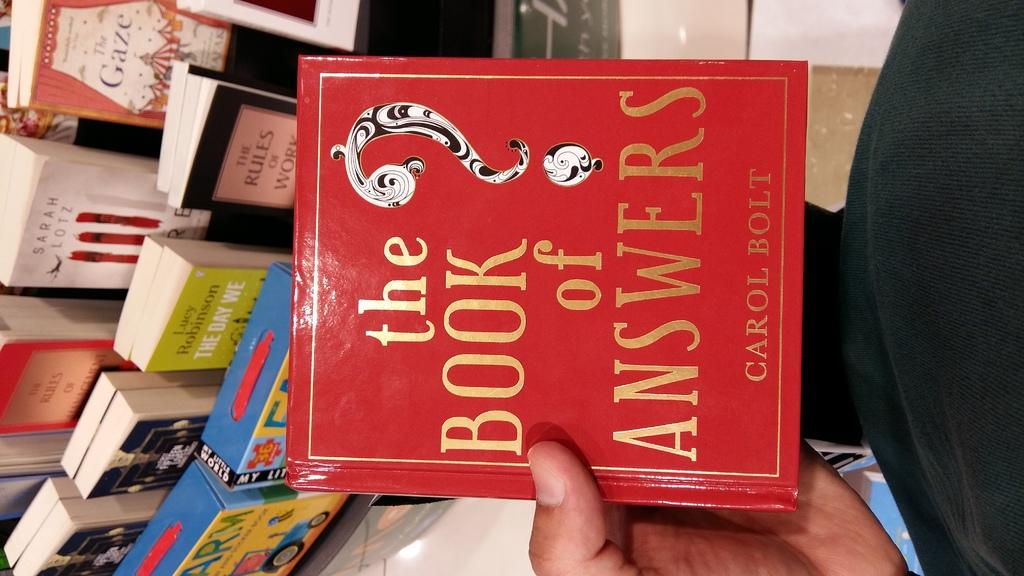Provide a one-sentence caption for the provided image. A person holding a book called the book of answers. 